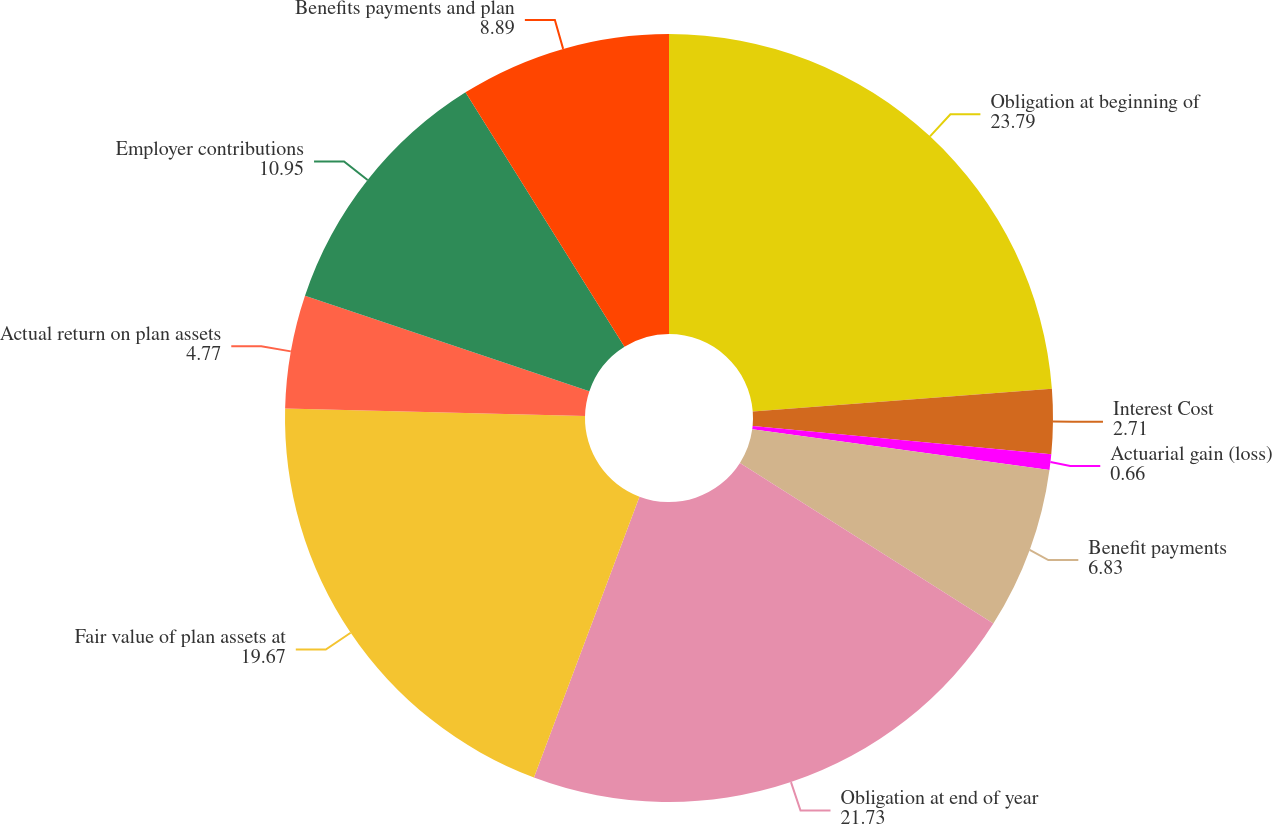Convert chart. <chart><loc_0><loc_0><loc_500><loc_500><pie_chart><fcel>Obligation at beginning of<fcel>Interest Cost<fcel>Actuarial gain (loss)<fcel>Benefit payments<fcel>Obligation at end of year<fcel>Fair value of plan assets at<fcel>Actual return on plan assets<fcel>Employer contributions<fcel>Benefits payments and plan<nl><fcel>23.79%<fcel>2.71%<fcel>0.66%<fcel>6.83%<fcel>21.73%<fcel>19.67%<fcel>4.77%<fcel>10.95%<fcel>8.89%<nl></chart> 